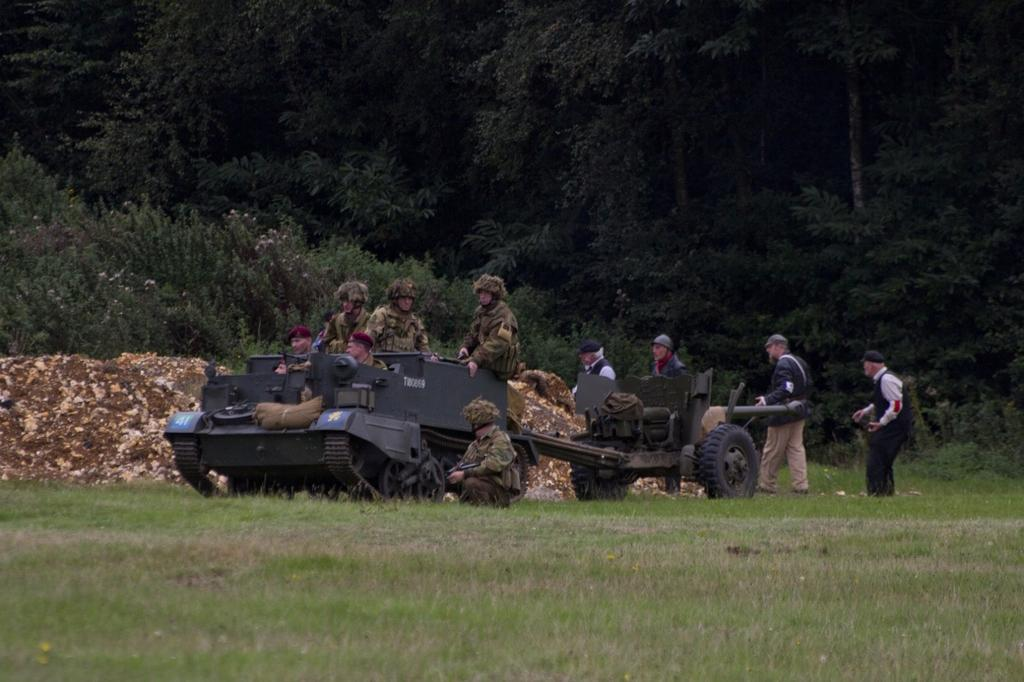What are the people sitting on in the image? There are people sitting on a panzer in the image. What other vehicle can be seen in the image? There is a mini tanker behind the panzer. What type of natural environment is visible in the background of the image? There are trees in the background of the image. What type of ground surface is present in the image? There is grass on the floor in the image. What type of powder is being used by the people in the image? There is no powder visible or mentioned in the image; the people are sitting on a panzer and there is a mini tanker behind it. 